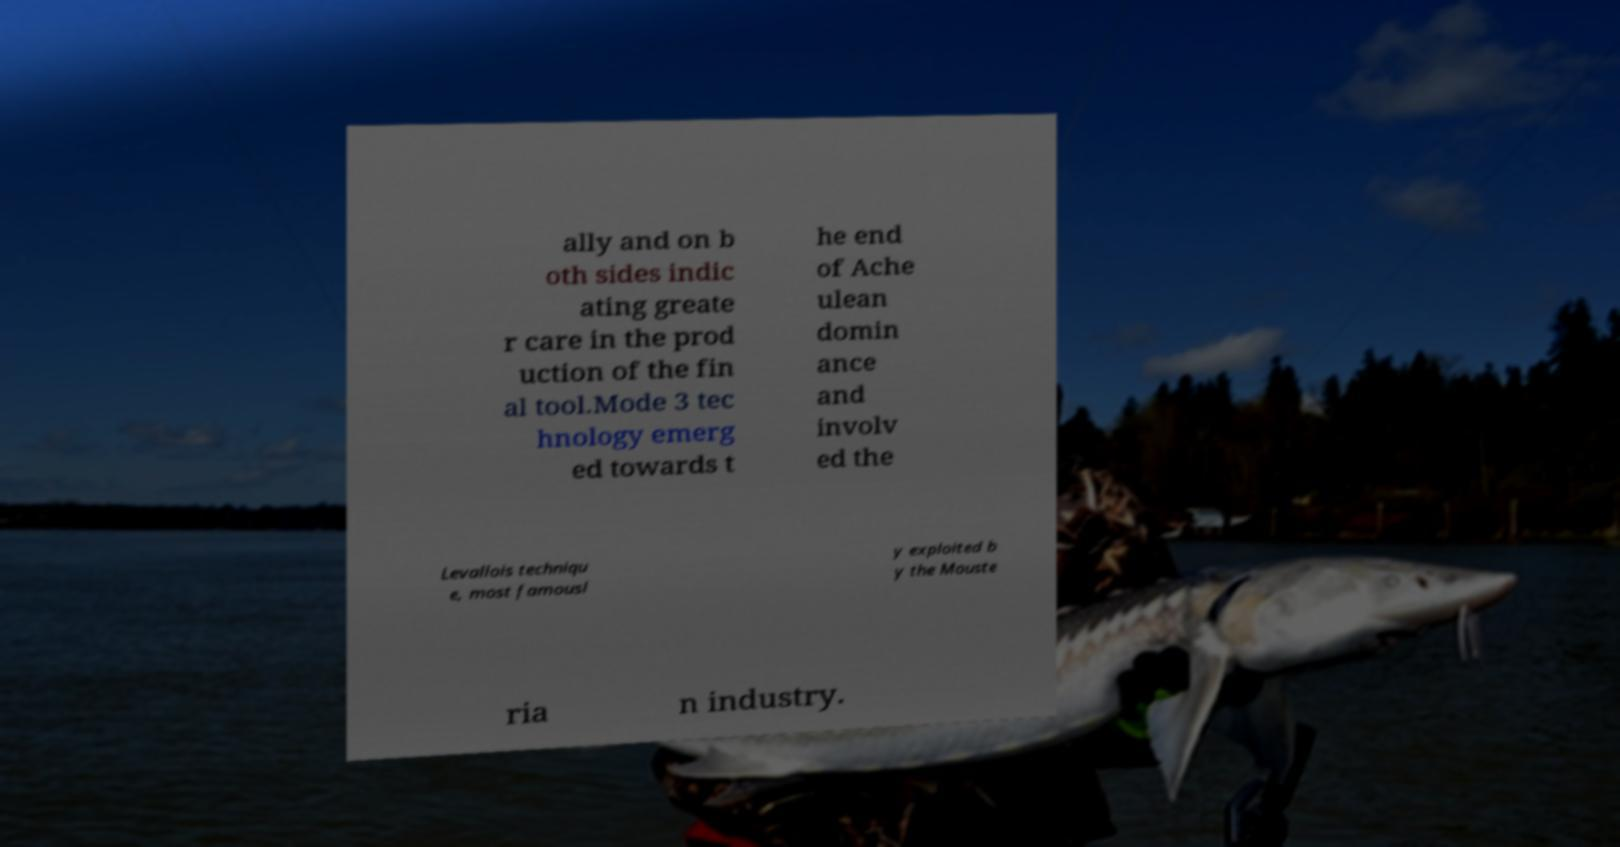Please read and relay the text visible in this image. What does it say? ally and on b oth sides indic ating greate r care in the prod uction of the fin al tool.Mode 3 tec hnology emerg ed towards t he end of Ache ulean domin ance and involv ed the Levallois techniqu e, most famousl y exploited b y the Mouste ria n industry. 